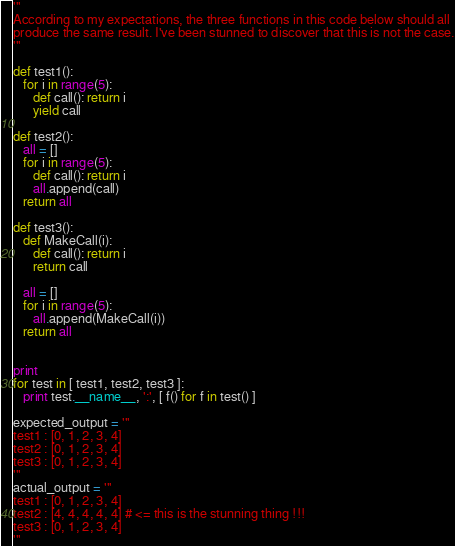Convert code to text. <code><loc_0><loc_0><loc_500><loc_500><_Python_>'''
According to my expectations, the three functions in this code below should all
produce the same result. I've been stunned to discover that this is not the case.
'''

def test1():
   for i in range(5):
      def call(): return i
      yield call

def test2():
   all = []
   for i in range(5):
      def call(): return i
      all.append(call)
   return all

def test3():
   def MakeCall(i):
      def call(): return i
      return call

   all = []
   for i in range(5):
      all.append(MakeCall(i))
   return all


print
for test in [ test1, test2, test3 ]:
   print test.__name__, ':', [ f() for f in test() ]

expected_output = '''
test1 : [0, 1, 2, 3, 4]
test2 : [0, 1, 2, 3, 4]
test3 : [0, 1, 2, 3, 4]
'''
actual_output = '''
test1 : [0, 1, 2, 3, 4]
test2 : [4, 4, 4, 4, 4] # <= this is the stunning thing !!!
test3 : [0, 1, 2, 3, 4]
'''
</code> 